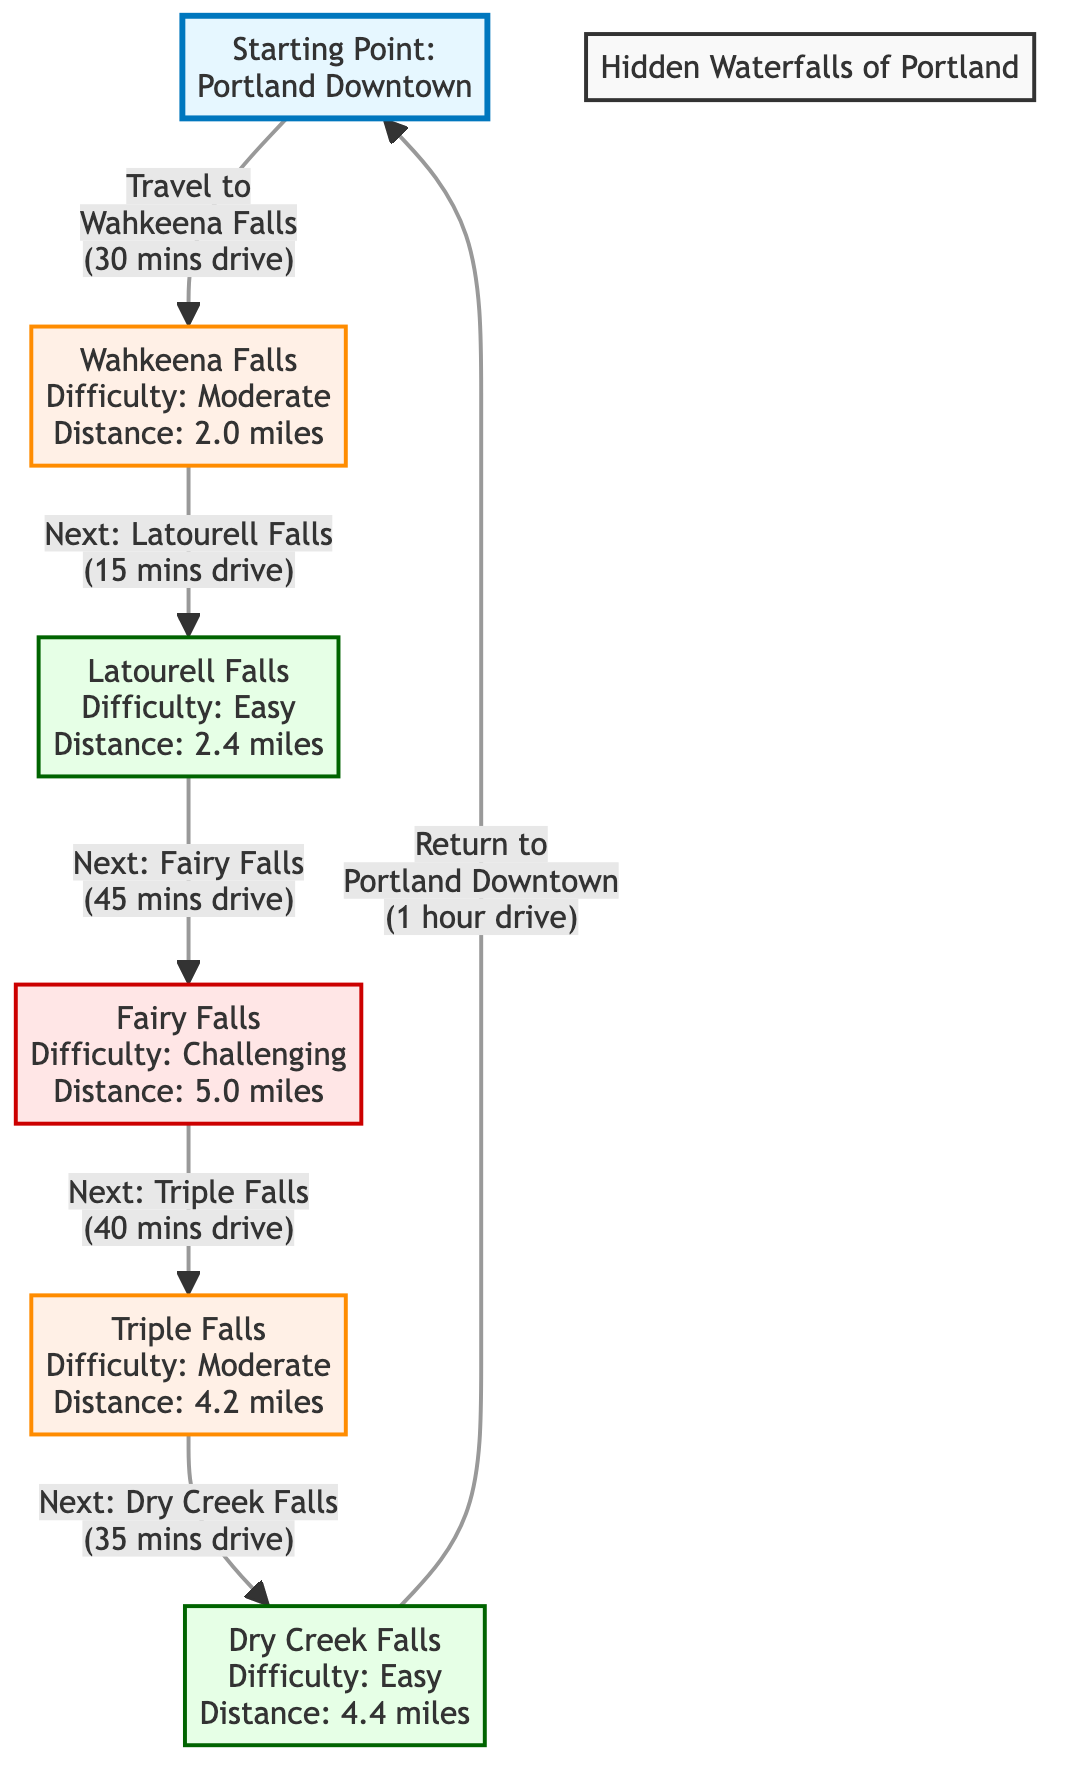What is the first waterfall listed in the diagram? The first waterfall in the flowchart is identified as "Wahkeena Falls" located after the starting point "Portland Downtown".
Answer: Wahkeena Falls How many miles is the distance to Latourell Falls from Wahkeena Falls? The diagram shows an arrow from Wahkeena Falls to Latourell Falls with a note indicating "Next: Latourell Falls (15 mins drive)". The distance to Latourell Falls is 2.4 miles, as stated in its description.
Answer: 2.4 miles What is the difficulty level of Fairy Falls? The description for Fairy Falls in the diagram indicates that it is classified as "Challenging".
Answer: Challenging Which waterfall has the longest distance to hike? Among the listed waterfalls, Fairy Falls has the longest distance at 5.0 miles, as shown in its node in the diagram.
Answer: 5.0 miles How many waterfalls are categorized as Easy? The flowchart includes two waterfalls categorized as Easy: Latourell Falls and Dry Creek Falls, as indicated by their color coding and descriptions in the diagram.
Answer: 2 What is the total driving time to visit all waterfalls before returning to Portland Downtown? Starting from Portland Downtown to Wahkeena Falls takes 30 minutes drive, from Wahkeena Falls to Latourell Falls takes 15 minutes, to Fairy Falls takes 45 minutes, to Triple Falls takes 40 minutes, and then to Dry Creek Falls takes 35 minutes. Adding these times gives a total of 30 + 15 + 45 + 40 + 35 = 165 minutes.
Answer: 165 minutes Which waterfall follows Dry Creek Falls? The diagram indicates that after Dry Creek Falls, the next move is to return to "Portland Downtown". Therefore, no additional waterfall follows it in the sequence.
Answer: Portland Downtown What color represents waterfalls that are classified as Moderate difficulty? In the diagram, the waterfalls classified as Moderate difficulty are represented in the color described as "fff0e6", which is a light orange shade.
Answer: Light orange What is the total number of waterfalls depicted in the diagram? There are five waterfalls depicted in the diagram: Wahkeena Falls, Latourell Falls, Fairy Falls, Triple Falls, and Dry Creek Falls.
Answer: 5 